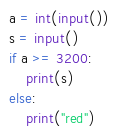Convert code to text. <code><loc_0><loc_0><loc_500><loc_500><_Python_>a = int(input())
s = input()
if a >= 3200:
	print(s)
else:
	print("red")
</code> 